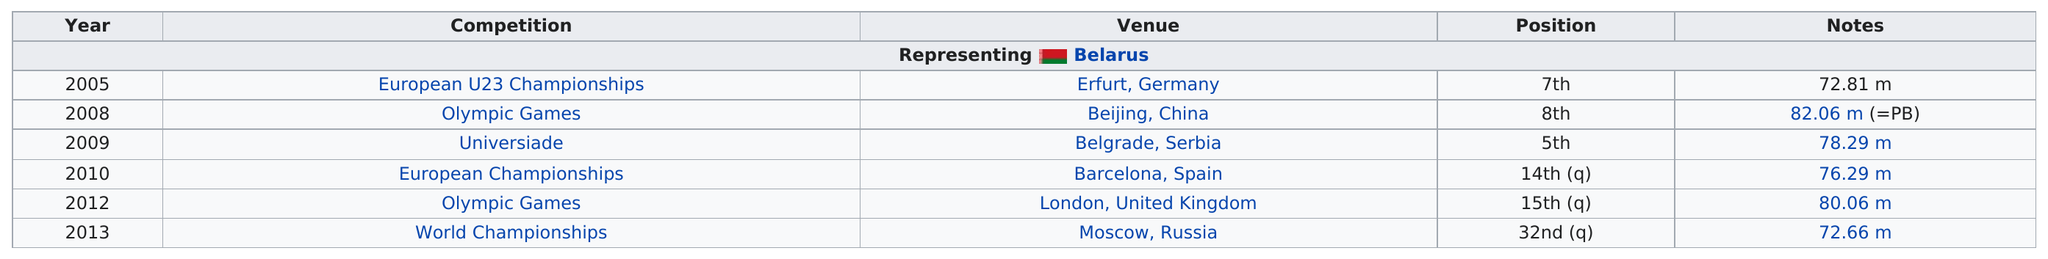Mention a couple of crucial points in this snapshot. Uladzimir Kazlou competed in a throwing event and achieved a distance of 82.06 meters, which was the furthest in that competition. For the past two consecutive Olympic Games, Uladzimir Kazlou has participated. Kazlou set a personal best of 82.06 meters in their longest throw in major international competition. The longest throw recorded is 82.06 meters. According to Kazlou's major world competition rankings, their two top positions were fifth and seventh. 